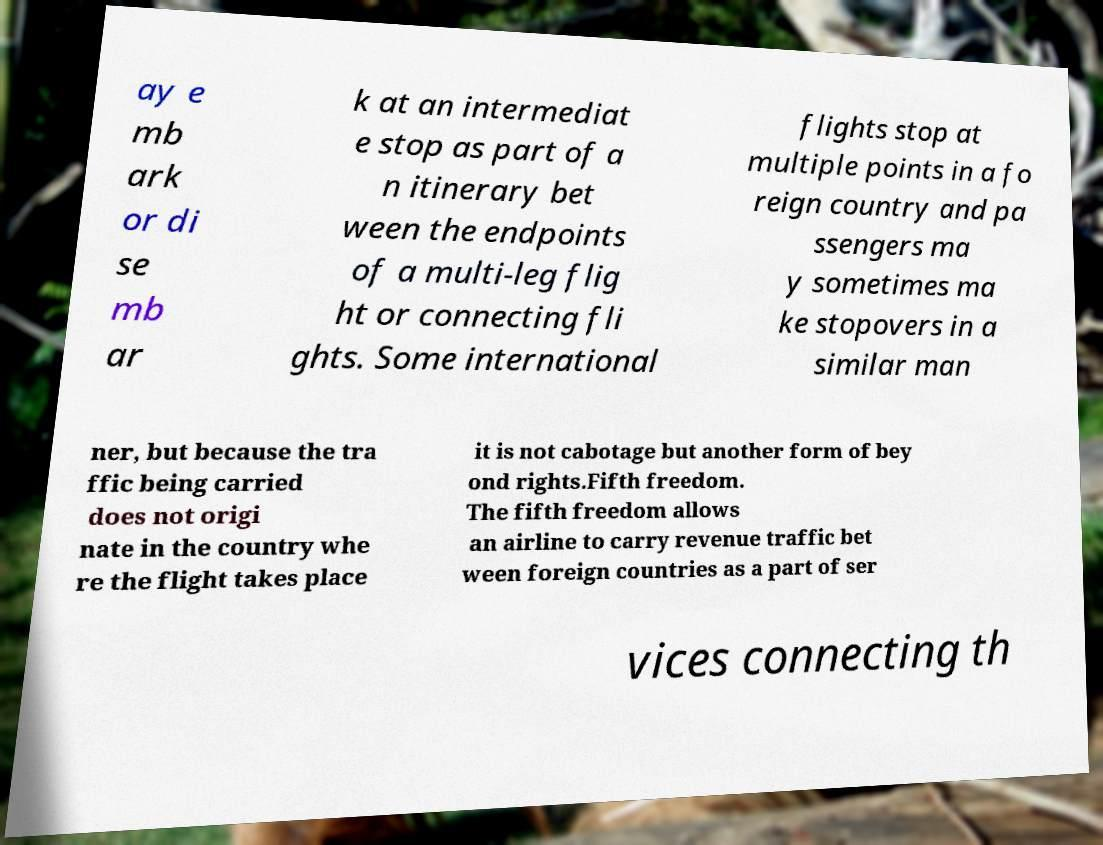There's text embedded in this image that I need extracted. Can you transcribe it verbatim? ay e mb ark or di se mb ar k at an intermediat e stop as part of a n itinerary bet ween the endpoints of a multi-leg flig ht or connecting fli ghts. Some international flights stop at multiple points in a fo reign country and pa ssengers ma y sometimes ma ke stopovers in a similar man ner, but because the tra ffic being carried does not origi nate in the country whe re the flight takes place it is not cabotage but another form of bey ond rights.Fifth freedom. The fifth freedom allows an airline to carry revenue traffic bet ween foreign countries as a part of ser vices connecting th 